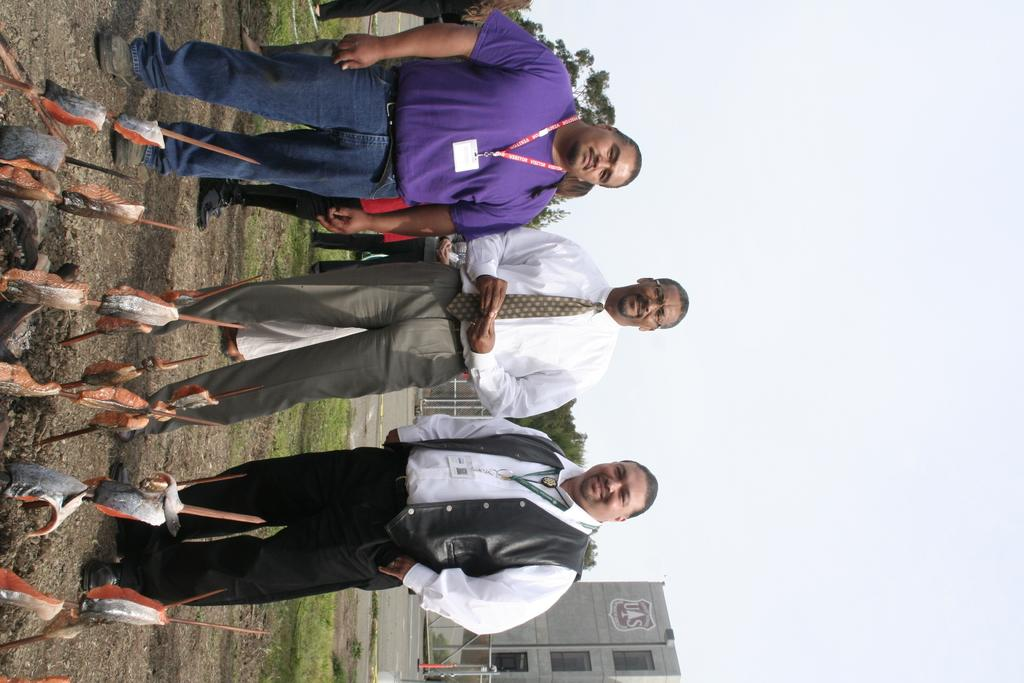How many people are standing in the image? There are three persons standing on the ground in the image. What can be seen in the image besides the people? Poles, buildings, trees, a fence, and the sky are visible in the image. What is the background of the image composed of? The background of the image includes buildings, trees, a fence, and the sky. What type of mine can be seen in the image? There is no mine present in the image; it features three persons standing on the ground, poles, buildings, trees, a fence, and the sky. 